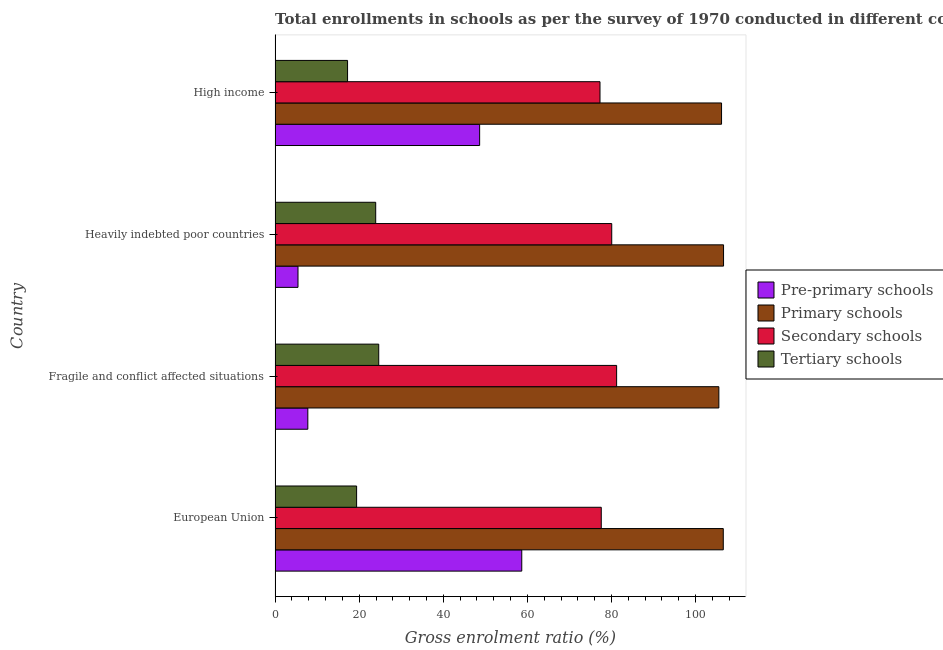How many different coloured bars are there?
Make the answer very short. 4. How many groups of bars are there?
Your answer should be compact. 4. How many bars are there on the 4th tick from the top?
Your answer should be very brief. 4. How many bars are there on the 1st tick from the bottom?
Provide a succinct answer. 4. What is the label of the 2nd group of bars from the top?
Your response must be concise. Heavily indebted poor countries. What is the gross enrolment ratio in primary schools in Fragile and conflict affected situations?
Make the answer very short. 105.53. Across all countries, what is the maximum gross enrolment ratio in secondary schools?
Provide a short and direct response. 81.22. Across all countries, what is the minimum gross enrolment ratio in primary schools?
Make the answer very short. 105.53. In which country was the gross enrolment ratio in tertiary schools maximum?
Give a very brief answer. Fragile and conflict affected situations. In which country was the gross enrolment ratio in primary schools minimum?
Give a very brief answer. Fragile and conflict affected situations. What is the total gross enrolment ratio in secondary schools in the graph?
Your answer should be compact. 316.12. What is the difference between the gross enrolment ratio in tertiary schools in Heavily indebted poor countries and that in High income?
Your answer should be compact. 6.69. What is the difference between the gross enrolment ratio in secondary schools in Heavily indebted poor countries and the gross enrolment ratio in primary schools in European Union?
Provide a short and direct response. -26.53. What is the average gross enrolment ratio in secondary schools per country?
Your answer should be compact. 79.03. What is the difference between the gross enrolment ratio in primary schools and gross enrolment ratio in secondary schools in Fragile and conflict affected situations?
Offer a terse response. 24.32. In how many countries, is the gross enrolment ratio in primary schools greater than 96 %?
Provide a succinct answer. 4. What is the ratio of the gross enrolment ratio in tertiary schools in Heavily indebted poor countries to that in High income?
Provide a succinct answer. 1.39. Is the gross enrolment ratio in tertiary schools in Fragile and conflict affected situations less than that in Heavily indebted poor countries?
Your answer should be compact. No. Is the difference between the gross enrolment ratio in secondary schools in European Union and High income greater than the difference between the gross enrolment ratio in primary schools in European Union and High income?
Make the answer very short. No. What is the difference between the highest and the second highest gross enrolment ratio in pre-primary schools?
Your answer should be compact. 10.02. What is the difference between the highest and the lowest gross enrolment ratio in tertiary schools?
Your answer should be compact. 7.41. Is the sum of the gross enrolment ratio in pre-primary schools in European Union and High income greater than the maximum gross enrolment ratio in secondary schools across all countries?
Offer a very short reply. Yes. What does the 2nd bar from the top in High income represents?
Offer a terse response. Secondary schools. What does the 4th bar from the bottom in European Union represents?
Keep it short and to the point. Tertiary schools. Is it the case that in every country, the sum of the gross enrolment ratio in pre-primary schools and gross enrolment ratio in primary schools is greater than the gross enrolment ratio in secondary schools?
Ensure brevity in your answer.  Yes. How many bars are there?
Provide a short and direct response. 16. How many countries are there in the graph?
Offer a very short reply. 4. What is the difference between two consecutive major ticks on the X-axis?
Give a very brief answer. 20. Are the values on the major ticks of X-axis written in scientific E-notation?
Offer a terse response. No. Does the graph contain grids?
Offer a very short reply. No. Where does the legend appear in the graph?
Your answer should be very brief. Center right. How many legend labels are there?
Provide a short and direct response. 4. What is the title of the graph?
Provide a succinct answer. Total enrollments in schools as per the survey of 1970 conducted in different countries. What is the Gross enrolment ratio (%) in Pre-primary schools in European Union?
Give a very brief answer. 58.66. What is the Gross enrolment ratio (%) in Primary schools in European Union?
Provide a short and direct response. 106.58. What is the Gross enrolment ratio (%) in Secondary schools in European Union?
Ensure brevity in your answer.  77.57. What is the Gross enrolment ratio (%) of Tertiary schools in European Union?
Offer a terse response. 19.39. What is the Gross enrolment ratio (%) in Pre-primary schools in Fragile and conflict affected situations?
Give a very brief answer. 7.79. What is the Gross enrolment ratio (%) in Primary schools in Fragile and conflict affected situations?
Your response must be concise. 105.53. What is the Gross enrolment ratio (%) of Secondary schools in Fragile and conflict affected situations?
Provide a short and direct response. 81.22. What is the Gross enrolment ratio (%) in Tertiary schools in Fragile and conflict affected situations?
Your response must be concise. 24.65. What is the Gross enrolment ratio (%) in Pre-primary schools in Heavily indebted poor countries?
Ensure brevity in your answer.  5.45. What is the Gross enrolment ratio (%) in Primary schools in Heavily indebted poor countries?
Make the answer very short. 106.65. What is the Gross enrolment ratio (%) of Secondary schools in Heavily indebted poor countries?
Provide a succinct answer. 80.06. What is the Gross enrolment ratio (%) of Tertiary schools in Heavily indebted poor countries?
Your response must be concise. 23.93. What is the Gross enrolment ratio (%) in Pre-primary schools in High income?
Your response must be concise. 48.64. What is the Gross enrolment ratio (%) of Primary schools in High income?
Your answer should be very brief. 106.17. What is the Gross enrolment ratio (%) of Secondary schools in High income?
Your answer should be very brief. 77.27. What is the Gross enrolment ratio (%) of Tertiary schools in High income?
Your response must be concise. 17.24. Across all countries, what is the maximum Gross enrolment ratio (%) in Pre-primary schools?
Ensure brevity in your answer.  58.66. Across all countries, what is the maximum Gross enrolment ratio (%) of Primary schools?
Give a very brief answer. 106.65. Across all countries, what is the maximum Gross enrolment ratio (%) of Secondary schools?
Make the answer very short. 81.22. Across all countries, what is the maximum Gross enrolment ratio (%) in Tertiary schools?
Offer a terse response. 24.65. Across all countries, what is the minimum Gross enrolment ratio (%) of Pre-primary schools?
Offer a terse response. 5.45. Across all countries, what is the minimum Gross enrolment ratio (%) of Primary schools?
Offer a terse response. 105.53. Across all countries, what is the minimum Gross enrolment ratio (%) in Secondary schools?
Offer a very short reply. 77.27. Across all countries, what is the minimum Gross enrolment ratio (%) in Tertiary schools?
Keep it short and to the point. 17.24. What is the total Gross enrolment ratio (%) in Pre-primary schools in the graph?
Your answer should be compact. 120.54. What is the total Gross enrolment ratio (%) in Primary schools in the graph?
Provide a short and direct response. 424.94. What is the total Gross enrolment ratio (%) of Secondary schools in the graph?
Ensure brevity in your answer.  316.12. What is the total Gross enrolment ratio (%) in Tertiary schools in the graph?
Your answer should be compact. 85.2. What is the difference between the Gross enrolment ratio (%) in Pre-primary schools in European Union and that in Fragile and conflict affected situations?
Ensure brevity in your answer.  50.88. What is the difference between the Gross enrolment ratio (%) of Primary schools in European Union and that in Fragile and conflict affected situations?
Offer a very short reply. 1.05. What is the difference between the Gross enrolment ratio (%) in Secondary schools in European Union and that in Fragile and conflict affected situations?
Give a very brief answer. -3.65. What is the difference between the Gross enrolment ratio (%) of Tertiary schools in European Union and that in Fragile and conflict affected situations?
Offer a very short reply. -5.26. What is the difference between the Gross enrolment ratio (%) in Pre-primary schools in European Union and that in Heavily indebted poor countries?
Keep it short and to the point. 53.21. What is the difference between the Gross enrolment ratio (%) in Primary schools in European Union and that in Heavily indebted poor countries?
Offer a very short reply. -0.06. What is the difference between the Gross enrolment ratio (%) in Secondary schools in European Union and that in Heavily indebted poor countries?
Offer a very short reply. -2.49. What is the difference between the Gross enrolment ratio (%) in Tertiary schools in European Union and that in Heavily indebted poor countries?
Ensure brevity in your answer.  -4.54. What is the difference between the Gross enrolment ratio (%) of Pre-primary schools in European Union and that in High income?
Offer a terse response. 10.02. What is the difference between the Gross enrolment ratio (%) of Primary schools in European Union and that in High income?
Make the answer very short. 0.41. What is the difference between the Gross enrolment ratio (%) of Secondary schools in European Union and that in High income?
Make the answer very short. 0.3. What is the difference between the Gross enrolment ratio (%) of Tertiary schools in European Union and that in High income?
Give a very brief answer. 2.15. What is the difference between the Gross enrolment ratio (%) in Pre-primary schools in Fragile and conflict affected situations and that in Heavily indebted poor countries?
Your response must be concise. 2.34. What is the difference between the Gross enrolment ratio (%) of Primary schools in Fragile and conflict affected situations and that in Heavily indebted poor countries?
Provide a succinct answer. -1.11. What is the difference between the Gross enrolment ratio (%) in Secondary schools in Fragile and conflict affected situations and that in Heavily indebted poor countries?
Provide a succinct answer. 1.16. What is the difference between the Gross enrolment ratio (%) in Tertiary schools in Fragile and conflict affected situations and that in Heavily indebted poor countries?
Offer a very short reply. 0.72. What is the difference between the Gross enrolment ratio (%) of Pre-primary schools in Fragile and conflict affected situations and that in High income?
Offer a terse response. -40.86. What is the difference between the Gross enrolment ratio (%) in Primary schools in Fragile and conflict affected situations and that in High income?
Provide a short and direct response. -0.64. What is the difference between the Gross enrolment ratio (%) of Secondary schools in Fragile and conflict affected situations and that in High income?
Your answer should be very brief. 3.95. What is the difference between the Gross enrolment ratio (%) of Tertiary schools in Fragile and conflict affected situations and that in High income?
Provide a short and direct response. 7.41. What is the difference between the Gross enrolment ratio (%) of Pre-primary schools in Heavily indebted poor countries and that in High income?
Make the answer very short. -43.2. What is the difference between the Gross enrolment ratio (%) in Primary schools in Heavily indebted poor countries and that in High income?
Provide a short and direct response. 0.48. What is the difference between the Gross enrolment ratio (%) of Secondary schools in Heavily indebted poor countries and that in High income?
Provide a succinct answer. 2.79. What is the difference between the Gross enrolment ratio (%) in Tertiary schools in Heavily indebted poor countries and that in High income?
Offer a terse response. 6.69. What is the difference between the Gross enrolment ratio (%) of Pre-primary schools in European Union and the Gross enrolment ratio (%) of Primary schools in Fragile and conflict affected situations?
Your response must be concise. -46.87. What is the difference between the Gross enrolment ratio (%) in Pre-primary schools in European Union and the Gross enrolment ratio (%) in Secondary schools in Fragile and conflict affected situations?
Provide a succinct answer. -22.56. What is the difference between the Gross enrolment ratio (%) in Pre-primary schools in European Union and the Gross enrolment ratio (%) in Tertiary schools in Fragile and conflict affected situations?
Your answer should be very brief. 34.01. What is the difference between the Gross enrolment ratio (%) in Primary schools in European Union and the Gross enrolment ratio (%) in Secondary schools in Fragile and conflict affected situations?
Your answer should be compact. 25.36. What is the difference between the Gross enrolment ratio (%) of Primary schools in European Union and the Gross enrolment ratio (%) of Tertiary schools in Fragile and conflict affected situations?
Offer a very short reply. 81.94. What is the difference between the Gross enrolment ratio (%) of Secondary schools in European Union and the Gross enrolment ratio (%) of Tertiary schools in Fragile and conflict affected situations?
Keep it short and to the point. 52.92. What is the difference between the Gross enrolment ratio (%) of Pre-primary schools in European Union and the Gross enrolment ratio (%) of Primary schools in Heavily indebted poor countries?
Your response must be concise. -47.99. What is the difference between the Gross enrolment ratio (%) of Pre-primary schools in European Union and the Gross enrolment ratio (%) of Secondary schools in Heavily indebted poor countries?
Offer a very short reply. -21.4. What is the difference between the Gross enrolment ratio (%) of Pre-primary schools in European Union and the Gross enrolment ratio (%) of Tertiary schools in Heavily indebted poor countries?
Provide a short and direct response. 34.73. What is the difference between the Gross enrolment ratio (%) in Primary schools in European Union and the Gross enrolment ratio (%) in Secondary schools in Heavily indebted poor countries?
Provide a succinct answer. 26.53. What is the difference between the Gross enrolment ratio (%) of Primary schools in European Union and the Gross enrolment ratio (%) of Tertiary schools in Heavily indebted poor countries?
Ensure brevity in your answer.  82.65. What is the difference between the Gross enrolment ratio (%) in Secondary schools in European Union and the Gross enrolment ratio (%) in Tertiary schools in Heavily indebted poor countries?
Ensure brevity in your answer.  53.64. What is the difference between the Gross enrolment ratio (%) in Pre-primary schools in European Union and the Gross enrolment ratio (%) in Primary schools in High income?
Provide a succinct answer. -47.51. What is the difference between the Gross enrolment ratio (%) of Pre-primary schools in European Union and the Gross enrolment ratio (%) of Secondary schools in High income?
Your answer should be very brief. -18.61. What is the difference between the Gross enrolment ratio (%) of Pre-primary schools in European Union and the Gross enrolment ratio (%) of Tertiary schools in High income?
Offer a terse response. 41.43. What is the difference between the Gross enrolment ratio (%) in Primary schools in European Union and the Gross enrolment ratio (%) in Secondary schools in High income?
Offer a terse response. 29.32. What is the difference between the Gross enrolment ratio (%) in Primary schools in European Union and the Gross enrolment ratio (%) in Tertiary schools in High income?
Give a very brief answer. 89.35. What is the difference between the Gross enrolment ratio (%) of Secondary schools in European Union and the Gross enrolment ratio (%) of Tertiary schools in High income?
Provide a succinct answer. 60.33. What is the difference between the Gross enrolment ratio (%) of Pre-primary schools in Fragile and conflict affected situations and the Gross enrolment ratio (%) of Primary schools in Heavily indebted poor countries?
Offer a very short reply. -98.86. What is the difference between the Gross enrolment ratio (%) of Pre-primary schools in Fragile and conflict affected situations and the Gross enrolment ratio (%) of Secondary schools in Heavily indebted poor countries?
Provide a succinct answer. -72.27. What is the difference between the Gross enrolment ratio (%) in Pre-primary schools in Fragile and conflict affected situations and the Gross enrolment ratio (%) in Tertiary schools in Heavily indebted poor countries?
Offer a terse response. -16.14. What is the difference between the Gross enrolment ratio (%) in Primary schools in Fragile and conflict affected situations and the Gross enrolment ratio (%) in Secondary schools in Heavily indebted poor countries?
Provide a succinct answer. 25.48. What is the difference between the Gross enrolment ratio (%) in Primary schools in Fragile and conflict affected situations and the Gross enrolment ratio (%) in Tertiary schools in Heavily indebted poor countries?
Provide a short and direct response. 81.6. What is the difference between the Gross enrolment ratio (%) of Secondary schools in Fragile and conflict affected situations and the Gross enrolment ratio (%) of Tertiary schools in Heavily indebted poor countries?
Provide a succinct answer. 57.29. What is the difference between the Gross enrolment ratio (%) in Pre-primary schools in Fragile and conflict affected situations and the Gross enrolment ratio (%) in Primary schools in High income?
Make the answer very short. -98.39. What is the difference between the Gross enrolment ratio (%) in Pre-primary schools in Fragile and conflict affected situations and the Gross enrolment ratio (%) in Secondary schools in High income?
Your answer should be compact. -69.48. What is the difference between the Gross enrolment ratio (%) of Pre-primary schools in Fragile and conflict affected situations and the Gross enrolment ratio (%) of Tertiary schools in High income?
Your answer should be very brief. -9.45. What is the difference between the Gross enrolment ratio (%) in Primary schools in Fragile and conflict affected situations and the Gross enrolment ratio (%) in Secondary schools in High income?
Your answer should be very brief. 28.27. What is the difference between the Gross enrolment ratio (%) of Primary schools in Fragile and conflict affected situations and the Gross enrolment ratio (%) of Tertiary schools in High income?
Offer a terse response. 88.3. What is the difference between the Gross enrolment ratio (%) in Secondary schools in Fragile and conflict affected situations and the Gross enrolment ratio (%) in Tertiary schools in High income?
Your answer should be compact. 63.98. What is the difference between the Gross enrolment ratio (%) of Pre-primary schools in Heavily indebted poor countries and the Gross enrolment ratio (%) of Primary schools in High income?
Keep it short and to the point. -100.72. What is the difference between the Gross enrolment ratio (%) in Pre-primary schools in Heavily indebted poor countries and the Gross enrolment ratio (%) in Secondary schools in High income?
Your answer should be very brief. -71.82. What is the difference between the Gross enrolment ratio (%) of Pre-primary schools in Heavily indebted poor countries and the Gross enrolment ratio (%) of Tertiary schools in High income?
Offer a very short reply. -11.79. What is the difference between the Gross enrolment ratio (%) in Primary schools in Heavily indebted poor countries and the Gross enrolment ratio (%) in Secondary schools in High income?
Make the answer very short. 29.38. What is the difference between the Gross enrolment ratio (%) in Primary schools in Heavily indebted poor countries and the Gross enrolment ratio (%) in Tertiary schools in High income?
Ensure brevity in your answer.  89.41. What is the difference between the Gross enrolment ratio (%) in Secondary schools in Heavily indebted poor countries and the Gross enrolment ratio (%) in Tertiary schools in High income?
Make the answer very short. 62.82. What is the average Gross enrolment ratio (%) in Pre-primary schools per country?
Offer a terse response. 30.14. What is the average Gross enrolment ratio (%) in Primary schools per country?
Your answer should be very brief. 106.23. What is the average Gross enrolment ratio (%) in Secondary schools per country?
Your answer should be very brief. 79.03. What is the average Gross enrolment ratio (%) of Tertiary schools per country?
Your response must be concise. 21.3. What is the difference between the Gross enrolment ratio (%) in Pre-primary schools and Gross enrolment ratio (%) in Primary schools in European Union?
Provide a succinct answer. -47.92. What is the difference between the Gross enrolment ratio (%) of Pre-primary schools and Gross enrolment ratio (%) of Secondary schools in European Union?
Make the answer very short. -18.91. What is the difference between the Gross enrolment ratio (%) of Pre-primary schools and Gross enrolment ratio (%) of Tertiary schools in European Union?
Your response must be concise. 39.27. What is the difference between the Gross enrolment ratio (%) in Primary schools and Gross enrolment ratio (%) in Secondary schools in European Union?
Provide a short and direct response. 29.01. What is the difference between the Gross enrolment ratio (%) of Primary schools and Gross enrolment ratio (%) of Tertiary schools in European Union?
Offer a terse response. 87.19. What is the difference between the Gross enrolment ratio (%) of Secondary schools and Gross enrolment ratio (%) of Tertiary schools in European Union?
Offer a terse response. 58.18. What is the difference between the Gross enrolment ratio (%) in Pre-primary schools and Gross enrolment ratio (%) in Primary schools in Fragile and conflict affected situations?
Provide a short and direct response. -97.75. What is the difference between the Gross enrolment ratio (%) of Pre-primary schools and Gross enrolment ratio (%) of Secondary schools in Fragile and conflict affected situations?
Provide a succinct answer. -73.43. What is the difference between the Gross enrolment ratio (%) in Pre-primary schools and Gross enrolment ratio (%) in Tertiary schools in Fragile and conflict affected situations?
Your response must be concise. -16.86. What is the difference between the Gross enrolment ratio (%) in Primary schools and Gross enrolment ratio (%) in Secondary schools in Fragile and conflict affected situations?
Your answer should be compact. 24.31. What is the difference between the Gross enrolment ratio (%) in Primary schools and Gross enrolment ratio (%) in Tertiary schools in Fragile and conflict affected situations?
Keep it short and to the point. 80.89. What is the difference between the Gross enrolment ratio (%) of Secondary schools and Gross enrolment ratio (%) of Tertiary schools in Fragile and conflict affected situations?
Make the answer very short. 56.57. What is the difference between the Gross enrolment ratio (%) in Pre-primary schools and Gross enrolment ratio (%) in Primary schools in Heavily indebted poor countries?
Your answer should be compact. -101.2. What is the difference between the Gross enrolment ratio (%) of Pre-primary schools and Gross enrolment ratio (%) of Secondary schools in Heavily indebted poor countries?
Offer a very short reply. -74.61. What is the difference between the Gross enrolment ratio (%) in Pre-primary schools and Gross enrolment ratio (%) in Tertiary schools in Heavily indebted poor countries?
Ensure brevity in your answer.  -18.48. What is the difference between the Gross enrolment ratio (%) in Primary schools and Gross enrolment ratio (%) in Secondary schools in Heavily indebted poor countries?
Offer a terse response. 26.59. What is the difference between the Gross enrolment ratio (%) of Primary schools and Gross enrolment ratio (%) of Tertiary schools in Heavily indebted poor countries?
Ensure brevity in your answer.  82.72. What is the difference between the Gross enrolment ratio (%) in Secondary schools and Gross enrolment ratio (%) in Tertiary schools in Heavily indebted poor countries?
Ensure brevity in your answer.  56.13. What is the difference between the Gross enrolment ratio (%) in Pre-primary schools and Gross enrolment ratio (%) in Primary schools in High income?
Provide a succinct answer. -57.53. What is the difference between the Gross enrolment ratio (%) of Pre-primary schools and Gross enrolment ratio (%) of Secondary schools in High income?
Offer a very short reply. -28.62. What is the difference between the Gross enrolment ratio (%) of Pre-primary schools and Gross enrolment ratio (%) of Tertiary schools in High income?
Offer a very short reply. 31.41. What is the difference between the Gross enrolment ratio (%) of Primary schools and Gross enrolment ratio (%) of Secondary schools in High income?
Give a very brief answer. 28.9. What is the difference between the Gross enrolment ratio (%) of Primary schools and Gross enrolment ratio (%) of Tertiary schools in High income?
Your answer should be compact. 88.94. What is the difference between the Gross enrolment ratio (%) in Secondary schools and Gross enrolment ratio (%) in Tertiary schools in High income?
Make the answer very short. 60.03. What is the ratio of the Gross enrolment ratio (%) in Pre-primary schools in European Union to that in Fragile and conflict affected situations?
Ensure brevity in your answer.  7.53. What is the ratio of the Gross enrolment ratio (%) of Primary schools in European Union to that in Fragile and conflict affected situations?
Your response must be concise. 1.01. What is the ratio of the Gross enrolment ratio (%) in Secondary schools in European Union to that in Fragile and conflict affected situations?
Offer a very short reply. 0.96. What is the ratio of the Gross enrolment ratio (%) in Tertiary schools in European Union to that in Fragile and conflict affected situations?
Offer a terse response. 0.79. What is the ratio of the Gross enrolment ratio (%) in Pre-primary schools in European Union to that in Heavily indebted poor countries?
Offer a terse response. 10.77. What is the ratio of the Gross enrolment ratio (%) in Secondary schools in European Union to that in Heavily indebted poor countries?
Keep it short and to the point. 0.97. What is the ratio of the Gross enrolment ratio (%) of Tertiary schools in European Union to that in Heavily indebted poor countries?
Make the answer very short. 0.81. What is the ratio of the Gross enrolment ratio (%) in Pre-primary schools in European Union to that in High income?
Offer a terse response. 1.21. What is the ratio of the Gross enrolment ratio (%) of Secondary schools in European Union to that in High income?
Provide a short and direct response. 1. What is the ratio of the Gross enrolment ratio (%) in Tertiary schools in European Union to that in High income?
Provide a short and direct response. 1.12. What is the ratio of the Gross enrolment ratio (%) of Pre-primary schools in Fragile and conflict affected situations to that in Heavily indebted poor countries?
Give a very brief answer. 1.43. What is the ratio of the Gross enrolment ratio (%) in Primary schools in Fragile and conflict affected situations to that in Heavily indebted poor countries?
Your response must be concise. 0.99. What is the ratio of the Gross enrolment ratio (%) in Secondary schools in Fragile and conflict affected situations to that in Heavily indebted poor countries?
Give a very brief answer. 1.01. What is the ratio of the Gross enrolment ratio (%) in Tertiary schools in Fragile and conflict affected situations to that in Heavily indebted poor countries?
Provide a short and direct response. 1.03. What is the ratio of the Gross enrolment ratio (%) of Pre-primary schools in Fragile and conflict affected situations to that in High income?
Make the answer very short. 0.16. What is the ratio of the Gross enrolment ratio (%) of Primary schools in Fragile and conflict affected situations to that in High income?
Offer a terse response. 0.99. What is the ratio of the Gross enrolment ratio (%) in Secondary schools in Fragile and conflict affected situations to that in High income?
Keep it short and to the point. 1.05. What is the ratio of the Gross enrolment ratio (%) in Tertiary schools in Fragile and conflict affected situations to that in High income?
Give a very brief answer. 1.43. What is the ratio of the Gross enrolment ratio (%) in Pre-primary schools in Heavily indebted poor countries to that in High income?
Give a very brief answer. 0.11. What is the ratio of the Gross enrolment ratio (%) in Secondary schools in Heavily indebted poor countries to that in High income?
Provide a short and direct response. 1.04. What is the ratio of the Gross enrolment ratio (%) of Tertiary schools in Heavily indebted poor countries to that in High income?
Keep it short and to the point. 1.39. What is the difference between the highest and the second highest Gross enrolment ratio (%) in Pre-primary schools?
Give a very brief answer. 10.02. What is the difference between the highest and the second highest Gross enrolment ratio (%) in Primary schools?
Your response must be concise. 0.06. What is the difference between the highest and the second highest Gross enrolment ratio (%) in Secondary schools?
Ensure brevity in your answer.  1.16. What is the difference between the highest and the second highest Gross enrolment ratio (%) in Tertiary schools?
Give a very brief answer. 0.72. What is the difference between the highest and the lowest Gross enrolment ratio (%) of Pre-primary schools?
Your answer should be compact. 53.21. What is the difference between the highest and the lowest Gross enrolment ratio (%) in Primary schools?
Offer a terse response. 1.11. What is the difference between the highest and the lowest Gross enrolment ratio (%) of Secondary schools?
Your response must be concise. 3.95. What is the difference between the highest and the lowest Gross enrolment ratio (%) of Tertiary schools?
Your answer should be very brief. 7.41. 